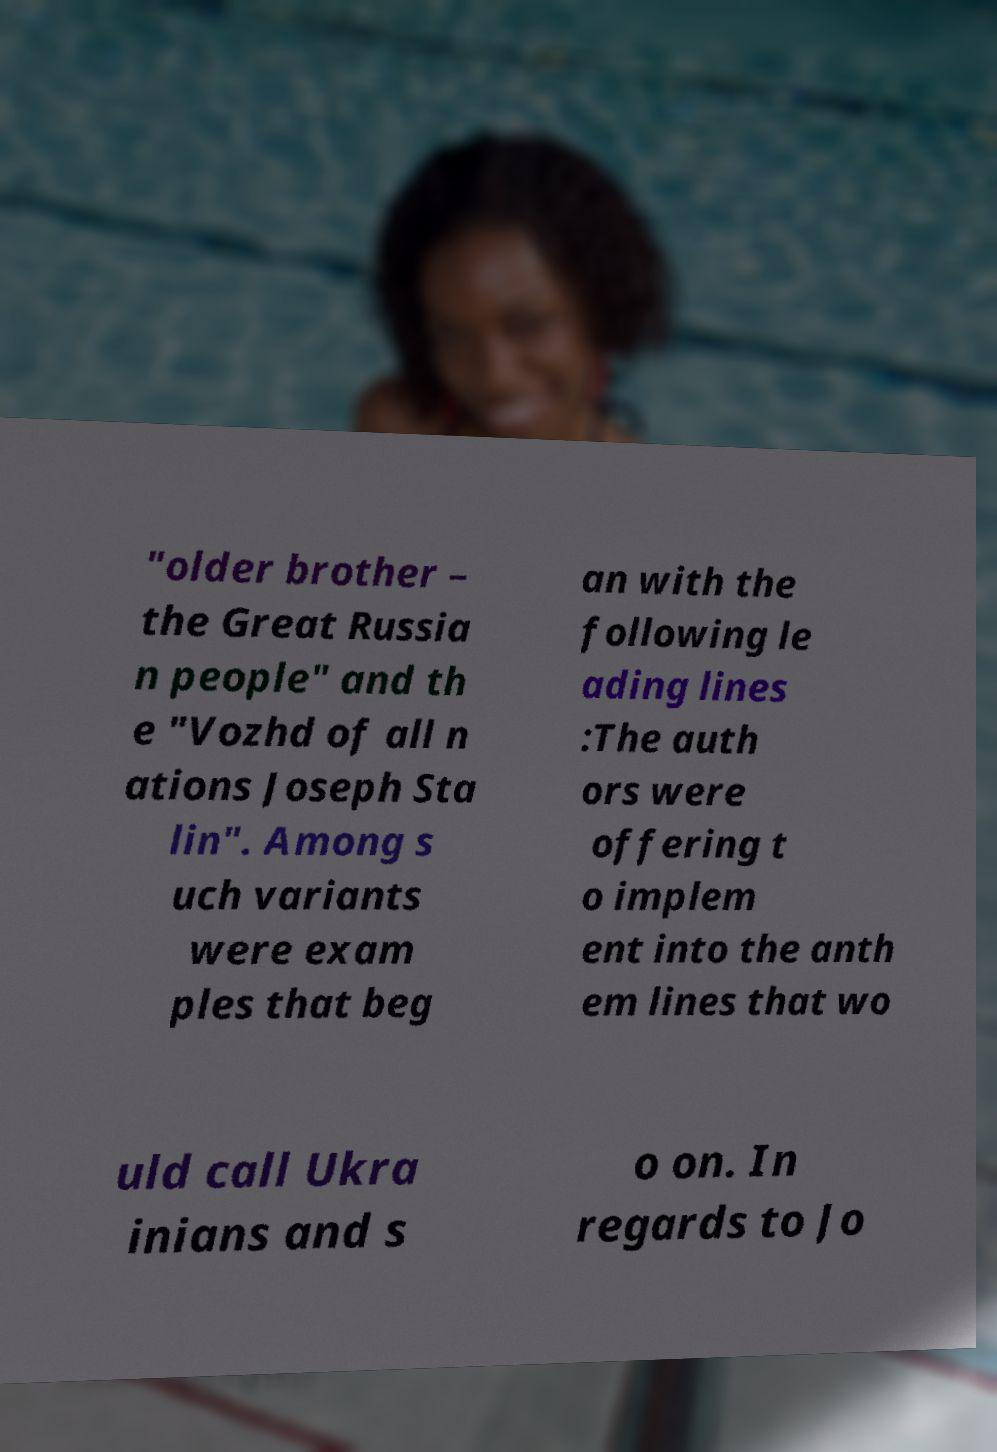For documentation purposes, I need the text within this image transcribed. Could you provide that? "older brother – the Great Russia n people" and th e "Vozhd of all n ations Joseph Sta lin". Among s uch variants were exam ples that beg an with the following le ading lines :The auth ors were offering t o implem ent into the anth em lines that wo uld call Ukra inians and s o on. In regards to Jo 